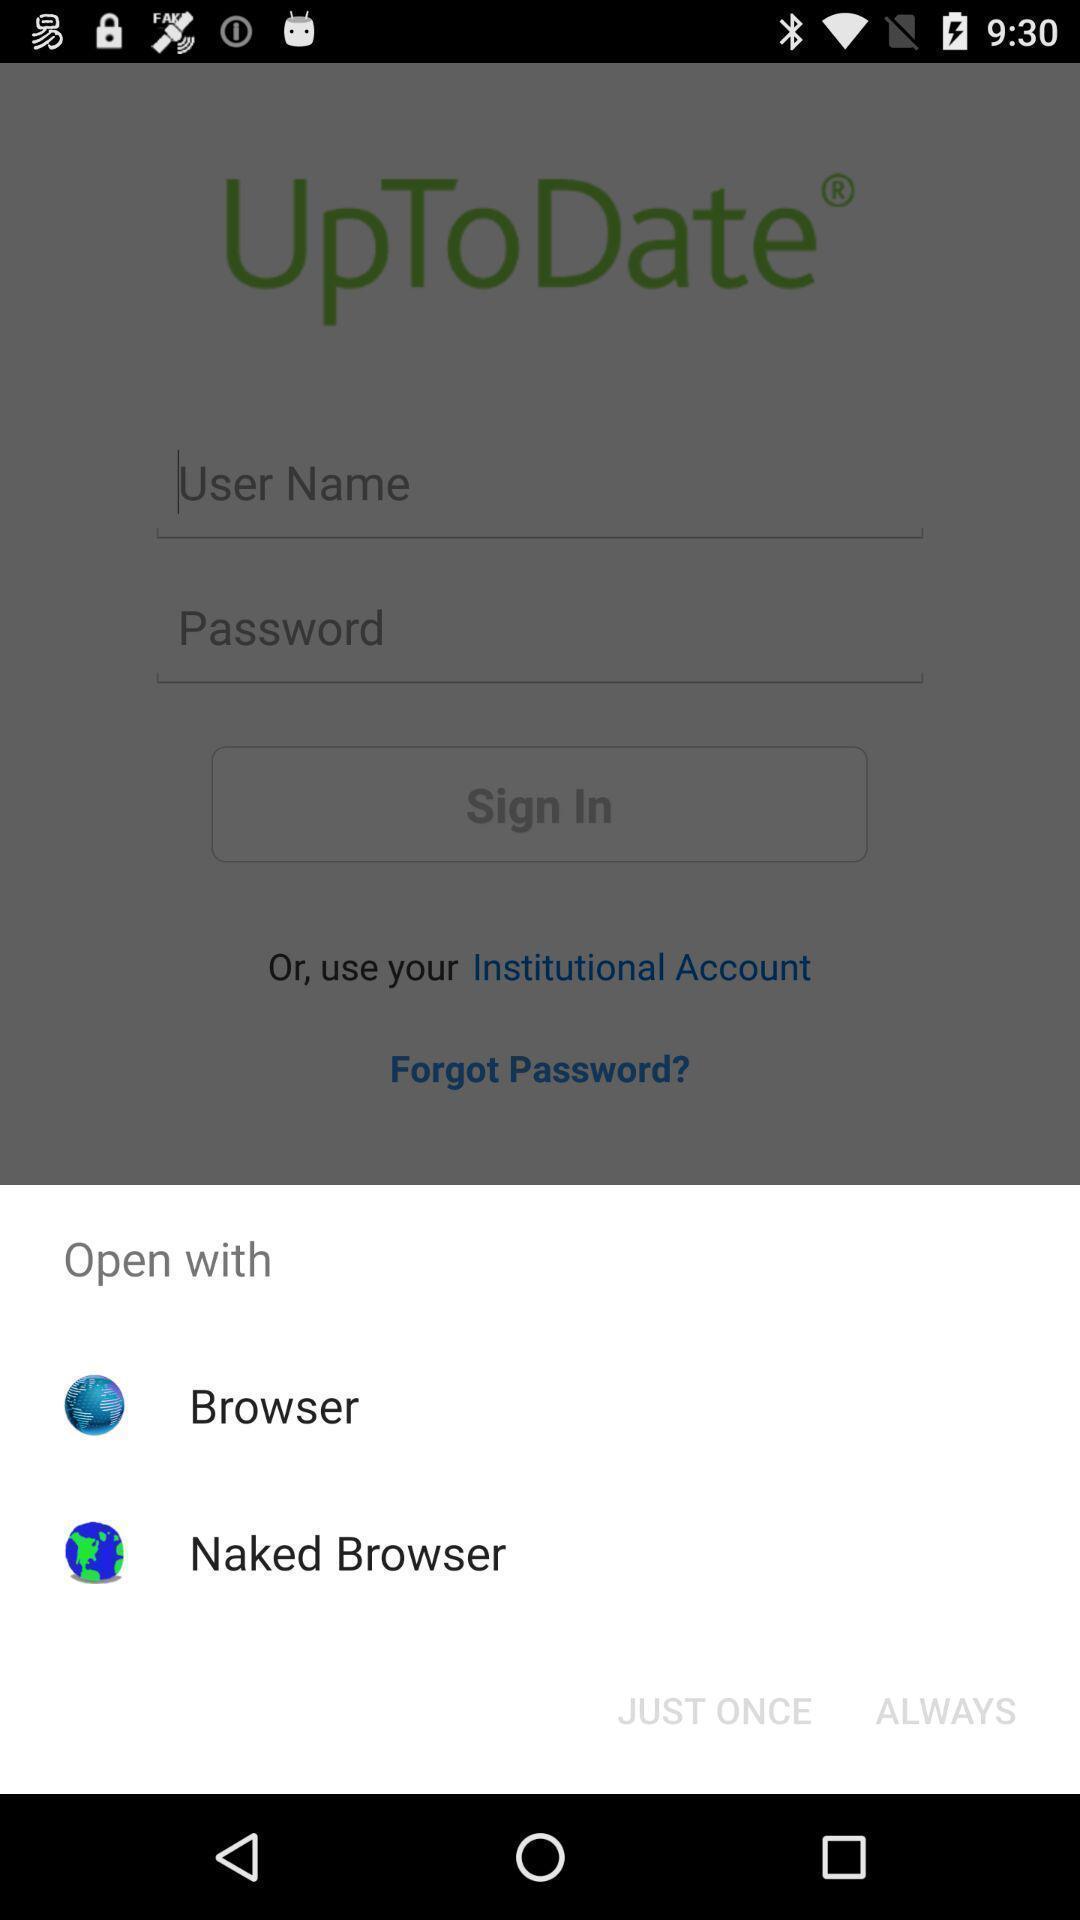Please provide a description for this image. Pop-up to open an application with multiple options. 